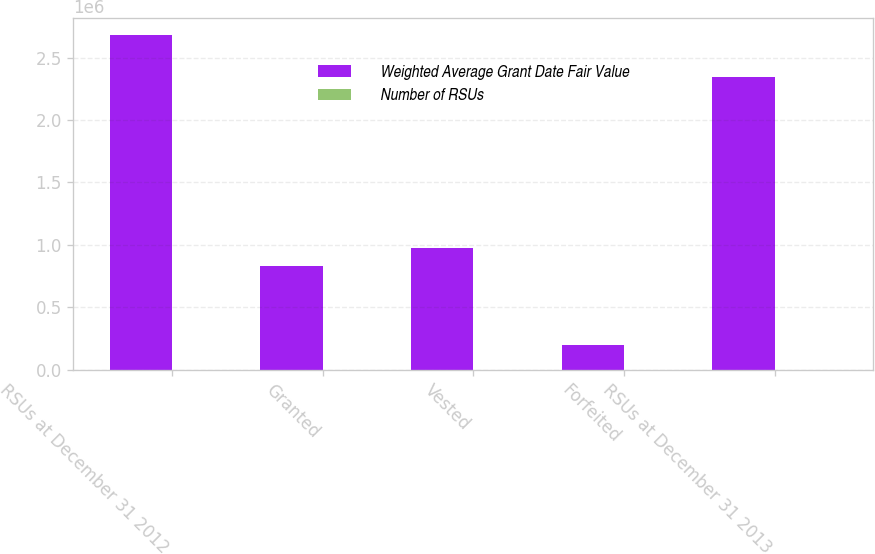Convert chart to OTSL. <chart><loc_0><loc_0><loc_500><loc_500><stacked_bar_chart><ecel><fcel>RSUs at December 31 2012<fcel>Granted<fcel>Vested<fcel>Forfeited<fcel>RSUs at December 31 2013<nl><fcel>Weighted Average Grant Date Fair Value<fcel>2.68076e+06<fcel>834435<fcel>974476<fcel>196043<fcel>2.34468e+06<nl><fcel>Number of RSUs<fcel>12.26<fcel>16.32<fcel>12<fcel>13.47<fcel>13.71<nl></chart> 